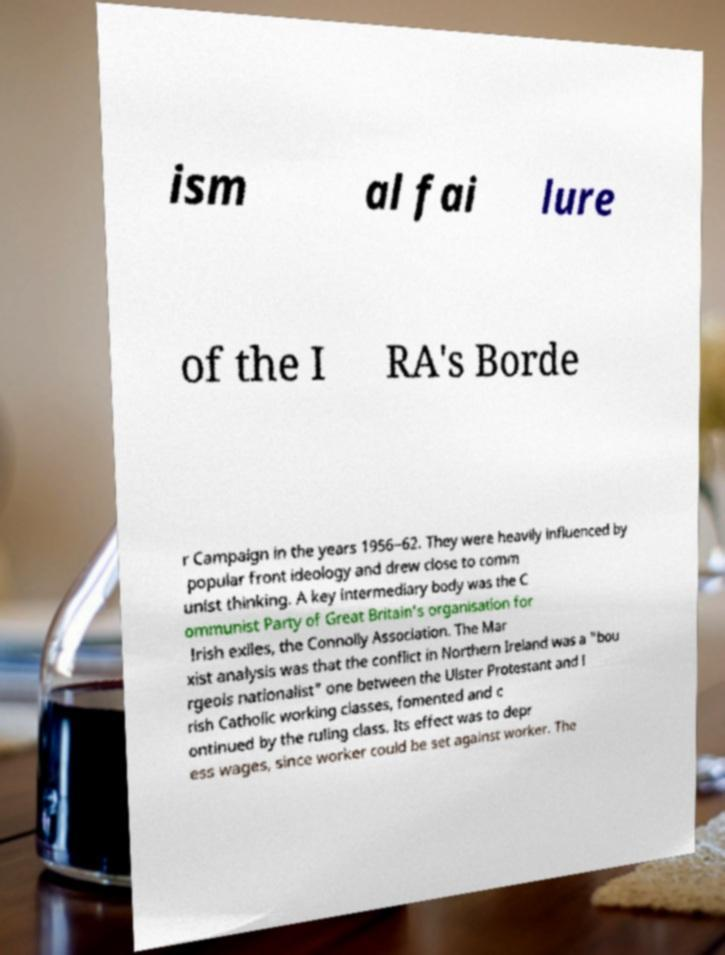Please identify and transcribe the text found in this image. ism al fai lure of the I RA's Borde r Campaign in the years 1956–62. They were heavily influenced by popular front ideology and drew close to comm unist thinking. A key intermediary body was the C ommunist Party of Great Britain's organisation for Irish exiles, the Connolly Association. The Mar xist analysis was that the conflict in Northern Ireland was a "bou rgeois nationalist" one between the Ulster Protestant and I rish Catholic working classes, fomented and c ontinued by the ruling class. Its effect was to depr ess wages, since worker could be set against worker. The 